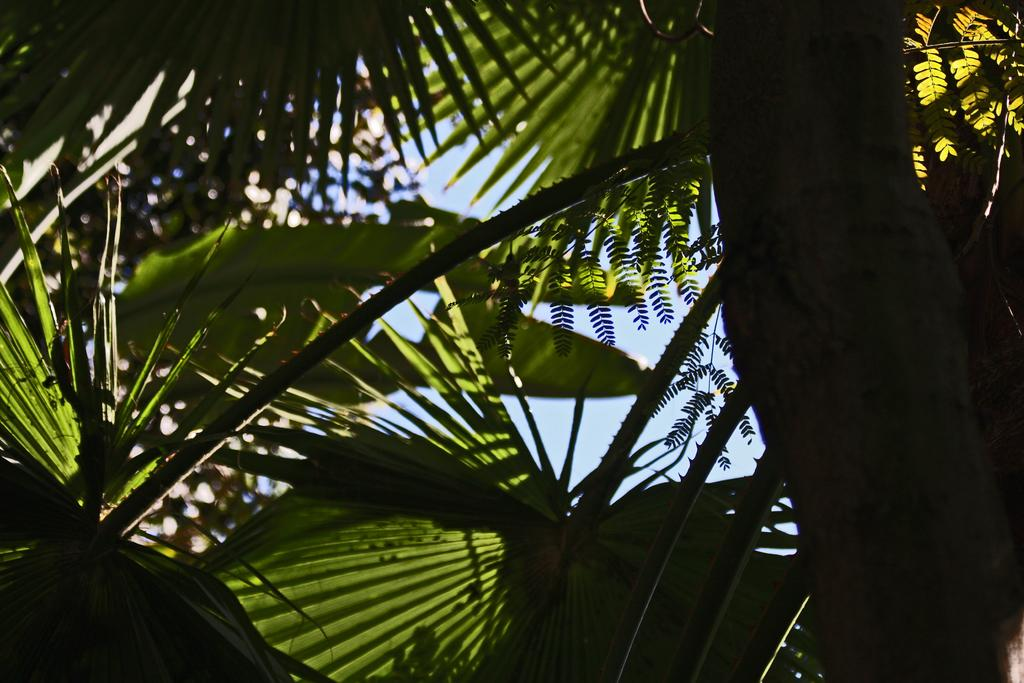What is the main subject of the picture? The main subject of the picture is a tree. Can you describe the tree in the picture? The tree has many long leaves. What part of the natural environment is visible in the picture? A part of the sky is visible in the picture. What type of power source can be seen in the image? There is no power source present in the image; it features a tree with long leaves and a part of the sky visible. Can you tell me how many snails are crawling on the tree in the image? There are no snails visible on the tree in the image; it only has long leaves. 